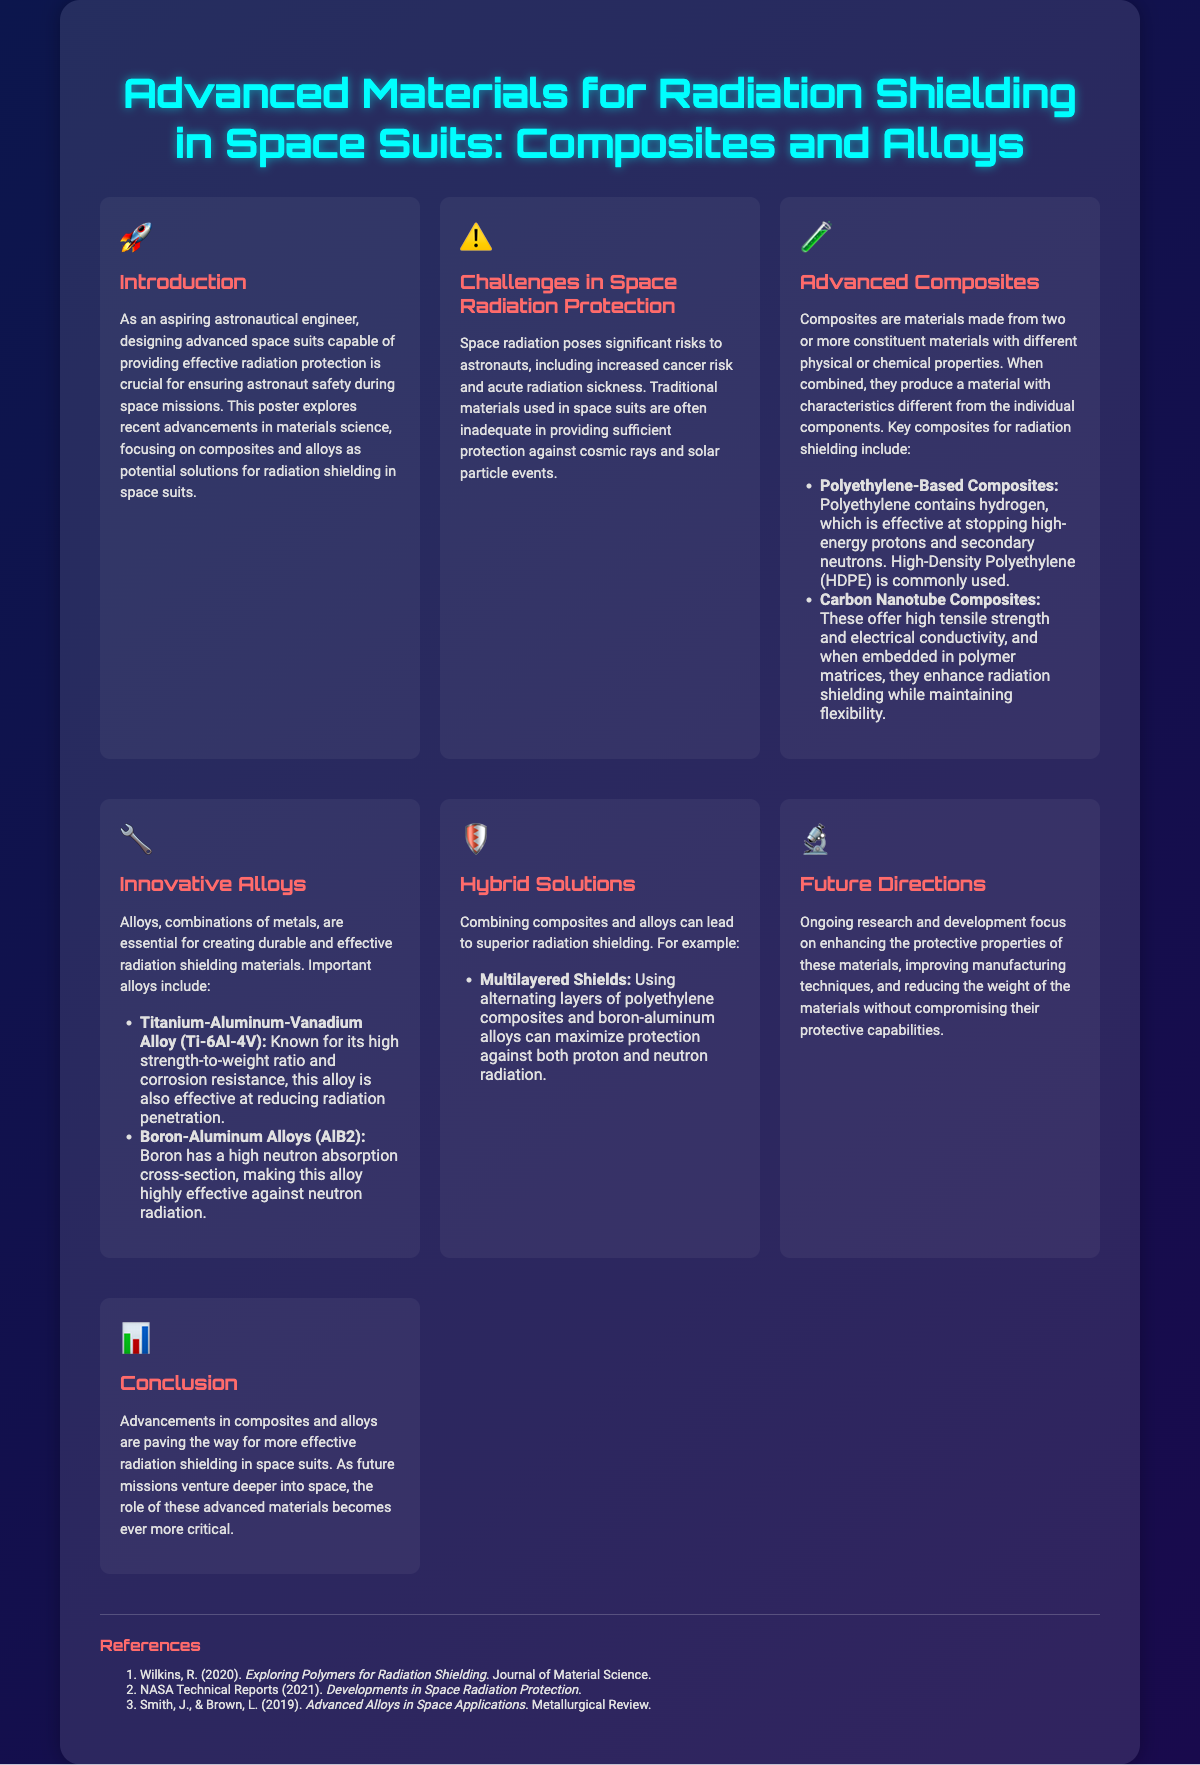What is the title of the poster? The title of the poster is specified at the top of the document.
Answer: Advanced Materials for Radiation Shielding in Space Suits: Composites and Alloys What are the two main types of materials discussed for radiation shielding? The poster categorizes materials into two main types for radiation shielding in space suits.
Answer: Composites and Alloys What is one challenge presented in radiation protection? The document states a challenge faced by space suits in the context of radiation protection.
Answer: Increased cancer risk Which composite is mentioned as effective against high-energy protons? The document lists specific composites and their properties.
Answer: Polyethylene-Based Composites What is the main benefit of using Titanium-Aluminum-Vanadium Alloy? The poster outlines the advantages of specific alloys used for radiation shielding.
Answer: High strength-to-weight ratio What type of solutions are proposed to enhance radiation protection? The document suggests a specific method to improve the effectiveness of radiation shielding.
Answer: Hybrid Solutions How does combining composites and alloys help in radiation shielding? The reasoning behind combining materials is explained in the hybrid solutions section of the poster.
Answer: Superior radiation shielding What year was a technical report from NASA on radiation protection published? The references section lists the publication years of various reports.
Answer: 2021 